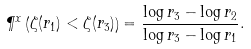<formula> <loc_0><loc_0><loc_500><loc_500>\P ^ { x } \left ( \zeta ( r _ { 1 } ) < \zeta ( r _ { 3 } ) \right ) = \frac { \log r _ { 3 } - \log r _ { 2 } } { \log r _ { 3 } - \log r _ { 1 } } .</formula> 